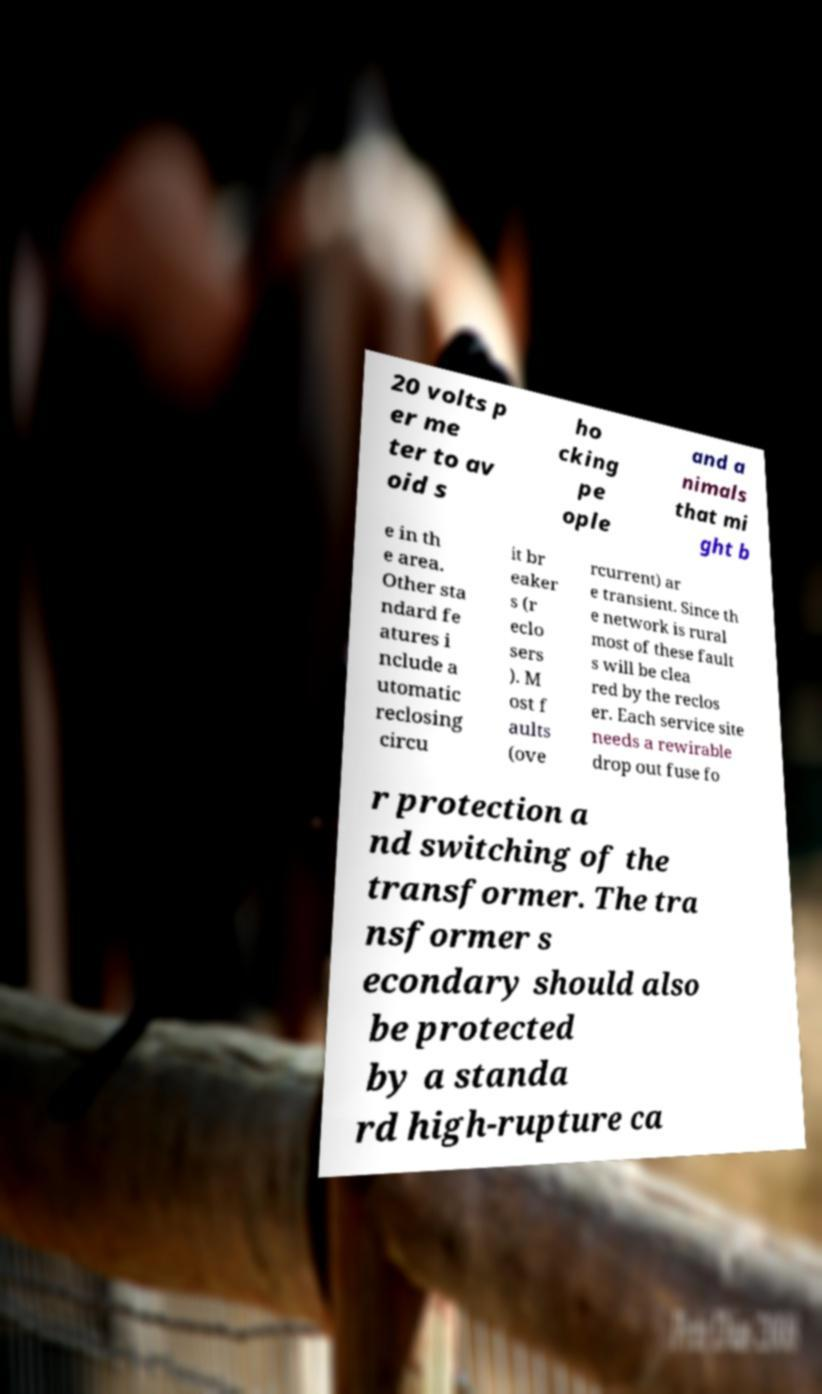Could you assist in decoding the text presented in this image and type it out clearly? 20 volts p er me ter to av oid s ho cking pe ople and a nimals that mi ght b e in th e area. Other sta ndard fe atures i nclude a utomatic reclosing circu it br eaker s (r eclo sers ). M ost f aults (ove rcurrent) ar e transient. Since th e network is rural most of these fault s will be clea red by the reclos er. Each service site needs a rewirable drop out fuse fo r protection a nd switching of the transformer. The tra nsformer s econdary should also be protected by a standa rd high-rupture ca 